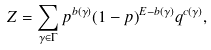<formula> <loc_0><loc_0><loc_500><loc_500>Z = \sum _ { \gamma \in \Gamma } p ^ { b ( \gamma ) } ( 1 - p ) ^ { E - b ( \gamma ) } q ^ { c ( \gamma ) } ,</formula> 